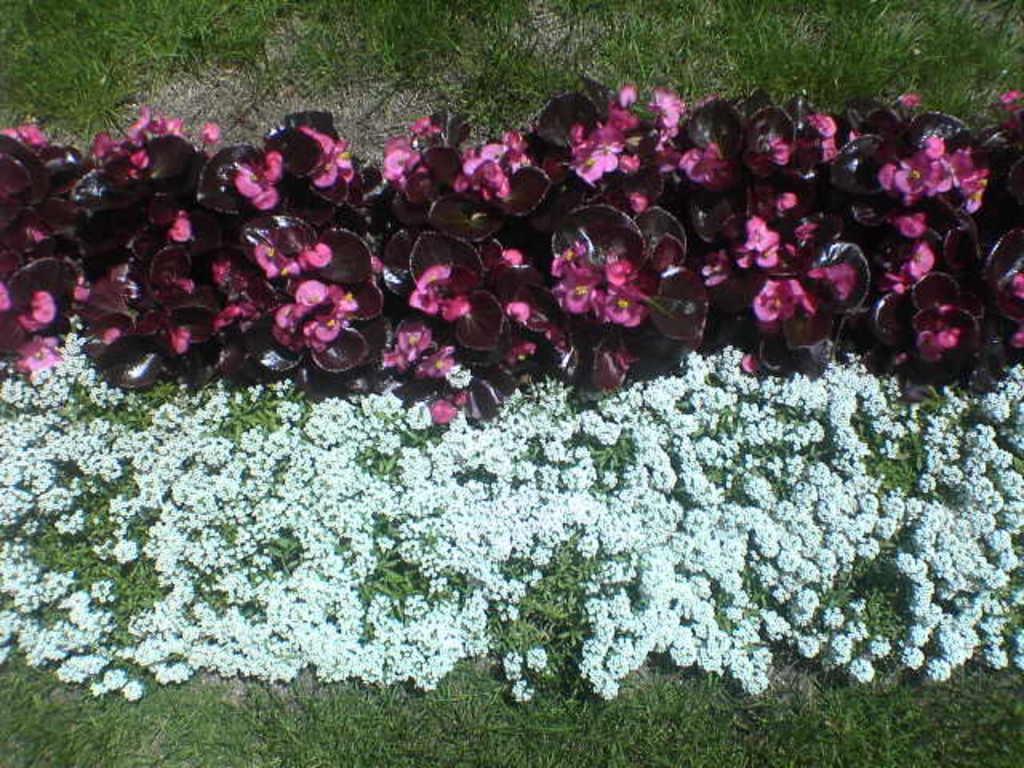How would you summarize this image in a sentence or two? In this picture I can see few plants and flowers and I can see grass on the ground. 